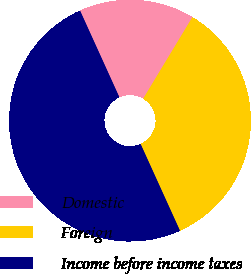Convert chart to OTSL. <chart><loc_0><loc_0><loc_500><loc_500><pie_chart><fcel>Domestic<fcel>Foreign<fcel>Income before income taxes<nl><fcel>15.43%<fcel>34.57%<fcel>50.0%<nl></chart> 